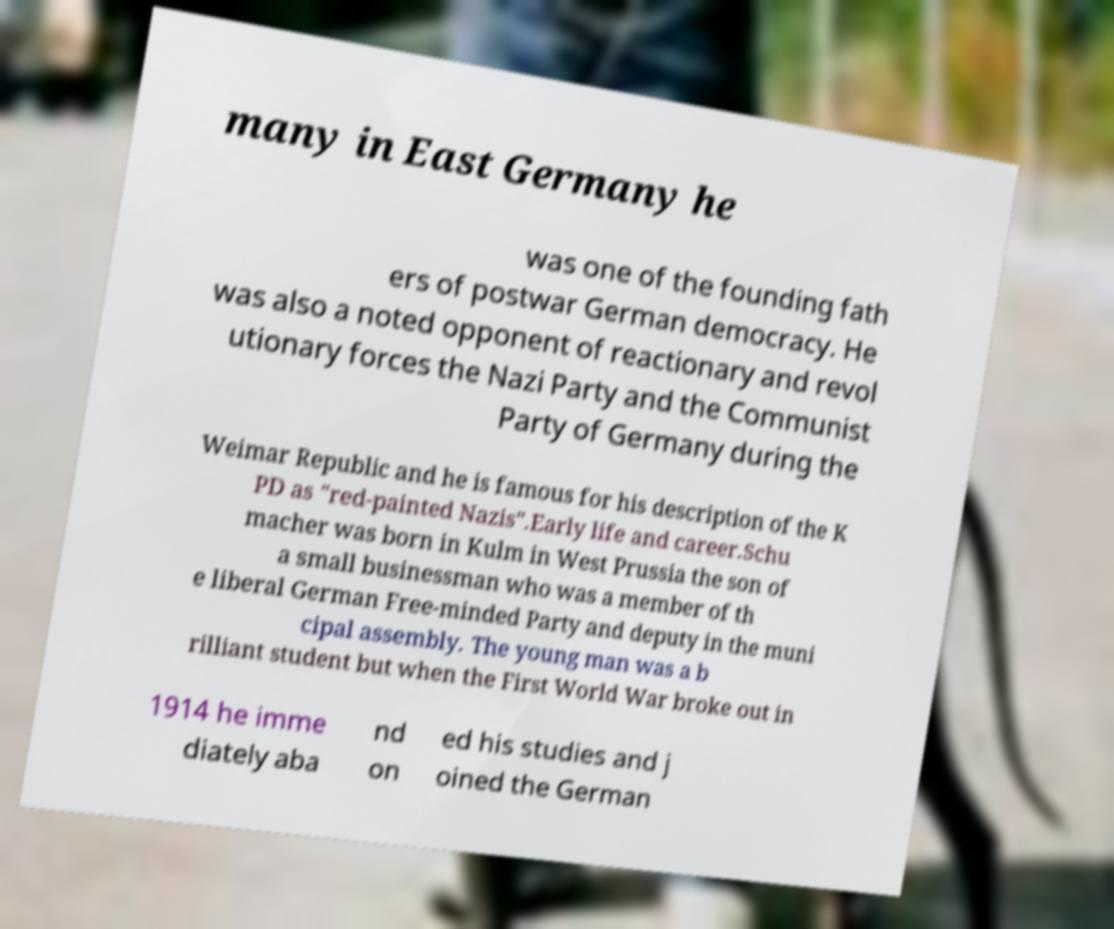Can you read and provide the text displayed in the image?This photo seems to have some interesting text. Can you extract and type it out for me? many in East Germany he was one of the founding fath ers of postwar German democracy. He was also a noted opponent of reactionary and revol utionary forces the Nazi Party and the Communist Party of Germany during the Weimar Republic and he is famous for his description of the K PD as "red-painted Nazis".Early life and career.Schu macher was born in Kulm in West Prussia the son of a small businessman who was a member of th e liberal German Free-minded Party and deputy in the muni cipal assembly. The young man was a b rilliant student but when the First World War broke out in 1914 he imme diately aba nd on ed his studies and j oined the German 